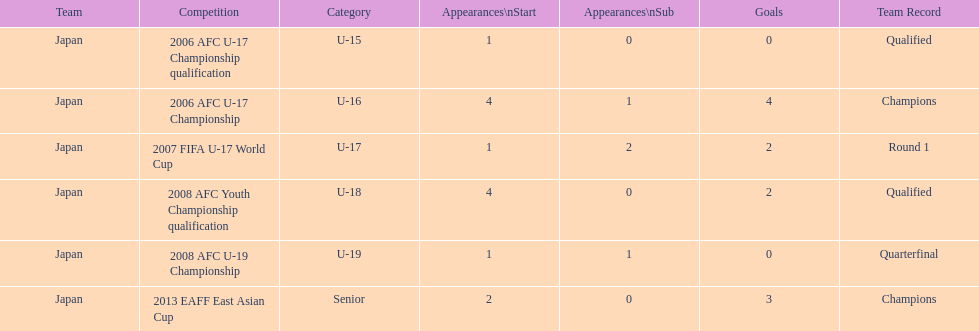In which two competitions did japan lack goals? 2006 AFC U-17 Championship qualification, 2008 AFC U-19 Championship. 